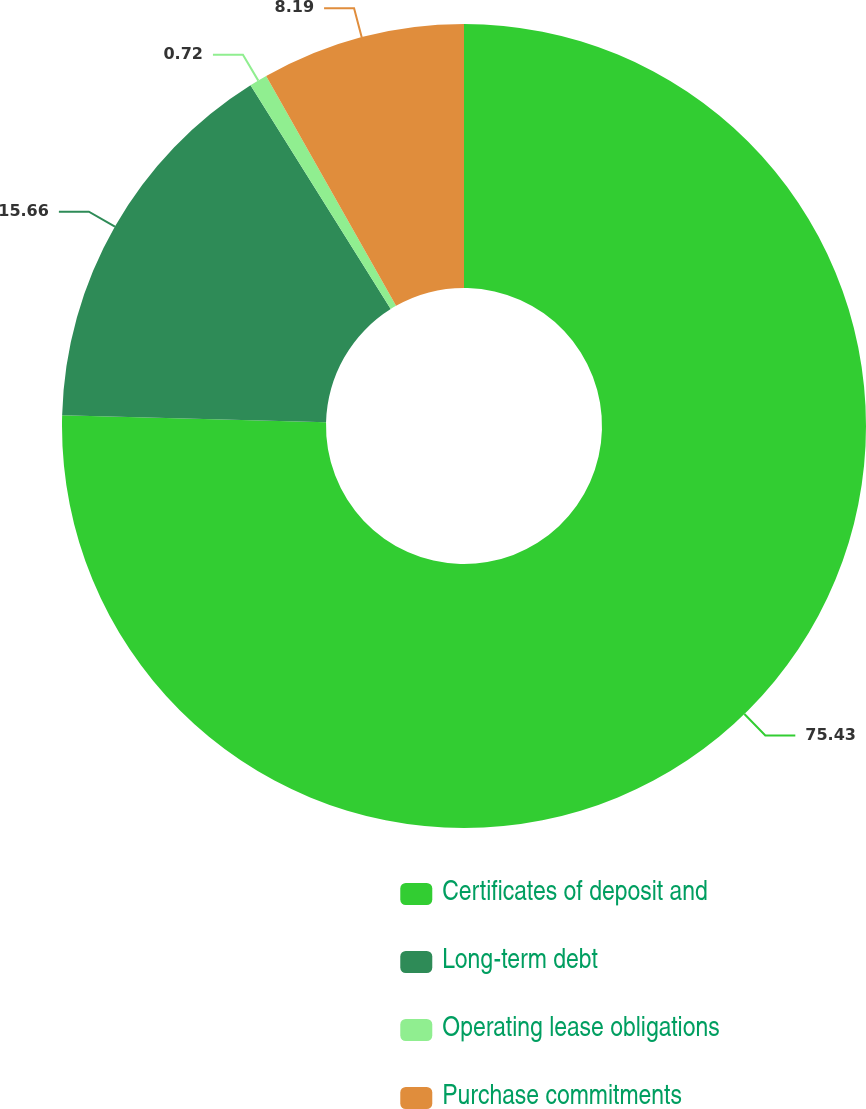Convert chart to OTSL. <chart><loc_0><loc_0><loc_500><loc_500><pie_chart><fcel>Certificates of deposit and<fcel>Long-term debt<fcel>Operating lease obligations<fcel>Purchase commitments<nl><fcel>75.43%<fcel>15.66%<fcel>0.72%<fcel>8.19%<nl></chart> 